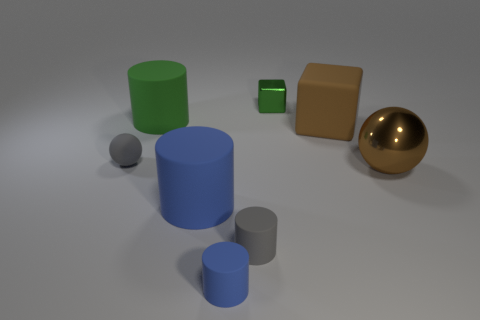Add 1 blue cylinders. How many objects exist? 9 Subtract all green blocks. How many blue cylinders are left? 2 Subtract all gray cylinders. How many cylinders are left? 3 Subtract all tiny blue rubber cylinders. How many cylinders are left? 3 Subtract all yellow cylinders. Subtract all brown balls. How many cylinders are left? 4 Subtract all large green matte balls. Subtract all small metal objects. How many objects are left? 7 Add 2 brown rubber things. How many brown rubber things are left? 3 Add 4 red metal balls. How many red metal balls exist? 4 Subtract 1 gray spheres. How many objects are left? 7 